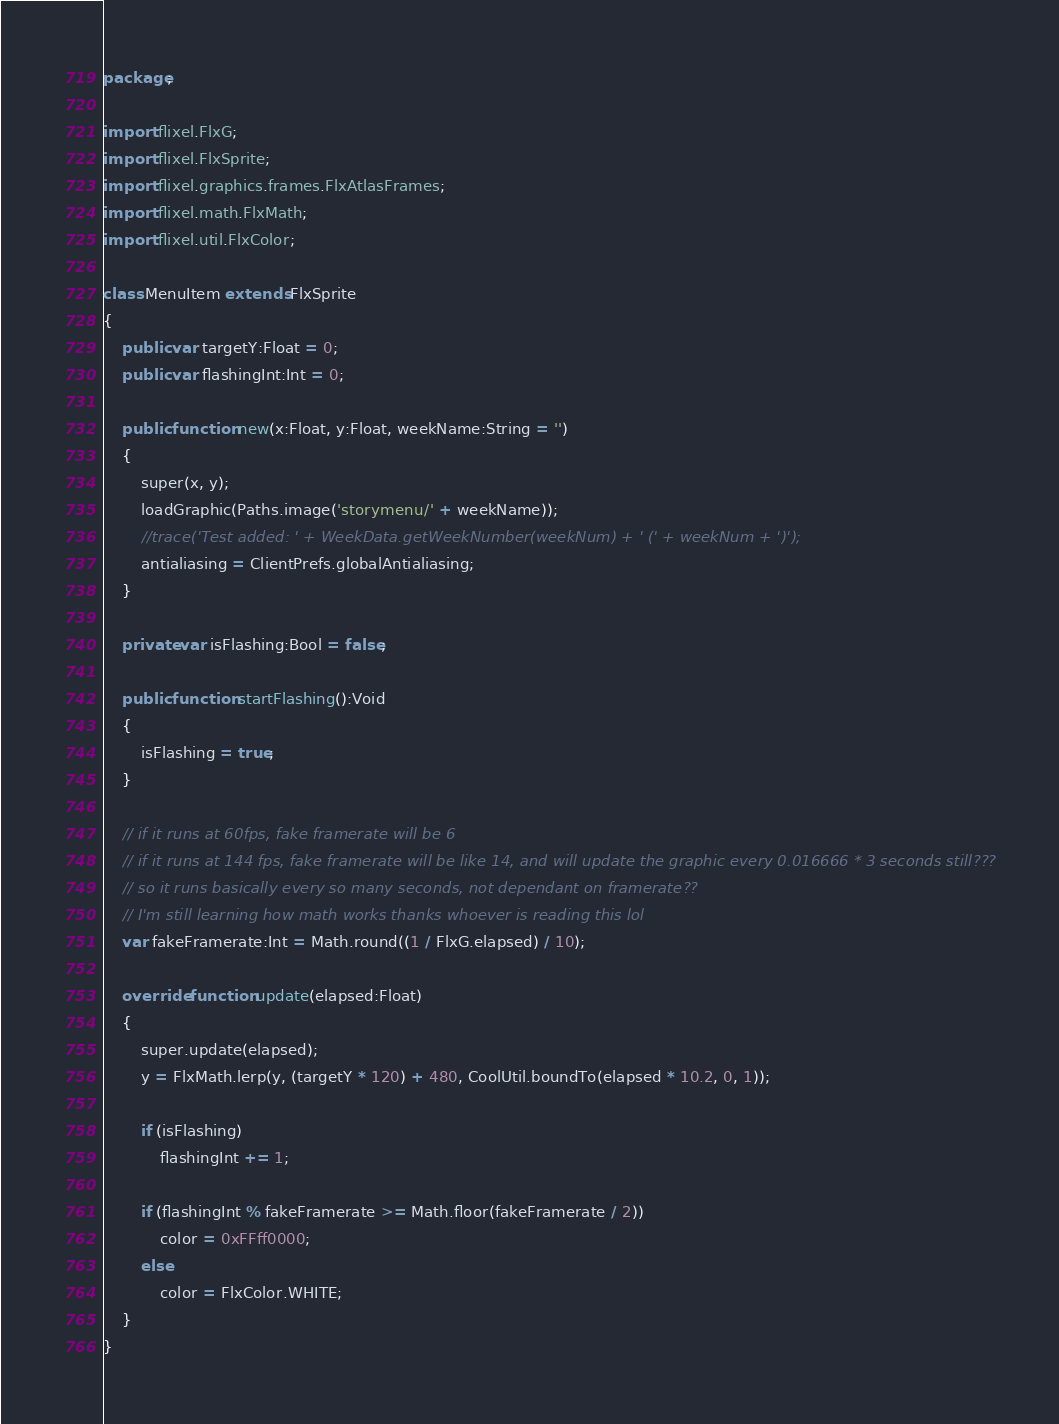Convert code to text. <code><loc_0><loc_0><loc_500><loc_500><_Haxe_>package;

import flixel.FlxG;
import flixel.FlxSprite;
import flixel.graphics.frames.FlxAtlasFrames;
import flixel.math.FlxMath;
import flixel.util.FlxColor;

class MenuItem extends FlxSprite
{
	public var targetY:Float = 0;
	public var flashingInt:Int = 0;

	public function new(x:Float, y:Float, weekName:String = '')
	{
		super(x, y);
		loadGraphic(Paths.image('storymenu/' + weekName));
		//trace('Test added: ' + WeekData.getWeekNumber(weekNum) + ' (' + weekNum + ')');
		antialiasing = ClientPrefs.globalAntialiasing;
	}

	private var isFlashing:Bool = false;

	public function startFlashing():Void
	{
		isFlashing = true;
	}

	// if it runs at 60fps, fake framerate will be 6
	// if it runs at 144 fps, fake framerate will be like 14, and will update the graphic every 0.016666 * 3 seconds still???
	// so it runs basically every so many seconds, not dependant on framerate??
	// I'm still learning how math works thanks whoever is reading this lol
	var fakeFramerate:Int = Math.round((1 / FlxG.elapsed) / 10);

	override function update(elapsed:Float)
	{
		super.update(elapsed);
		y = FlxMath.lerp(y, (targetY * 120) + 480, CoolUtil.boundTo(elapsed * 10.2, 0, 1));

		if (isFlashing)
			flashingInt += 1;

		if (flashingInt % fakeFramerate >= Math.floor(fakeFramerate / 2))
			color = 0xFFff0000;
		else
			color = FlxColor.WHITE;
	}
}
</code> 